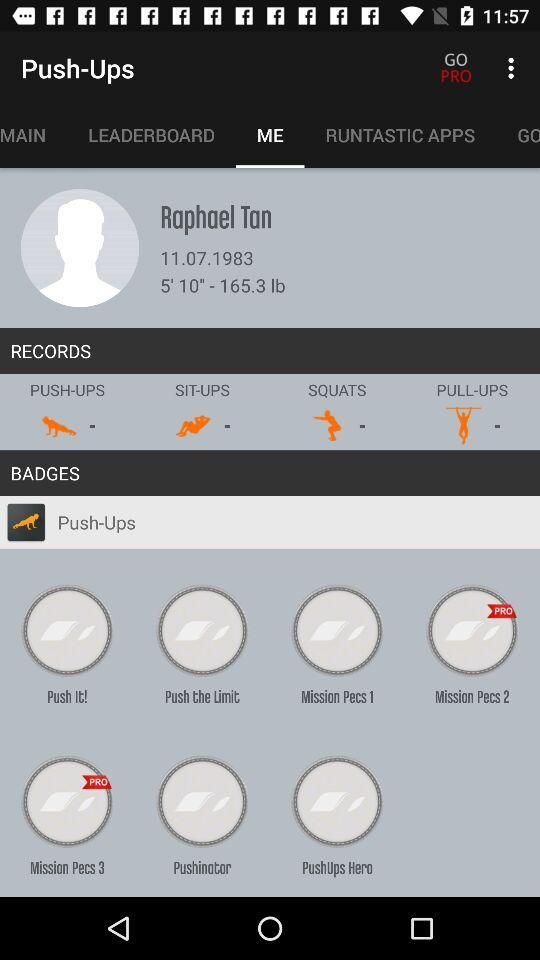Which tab is selected? The selected tab is "ME". 